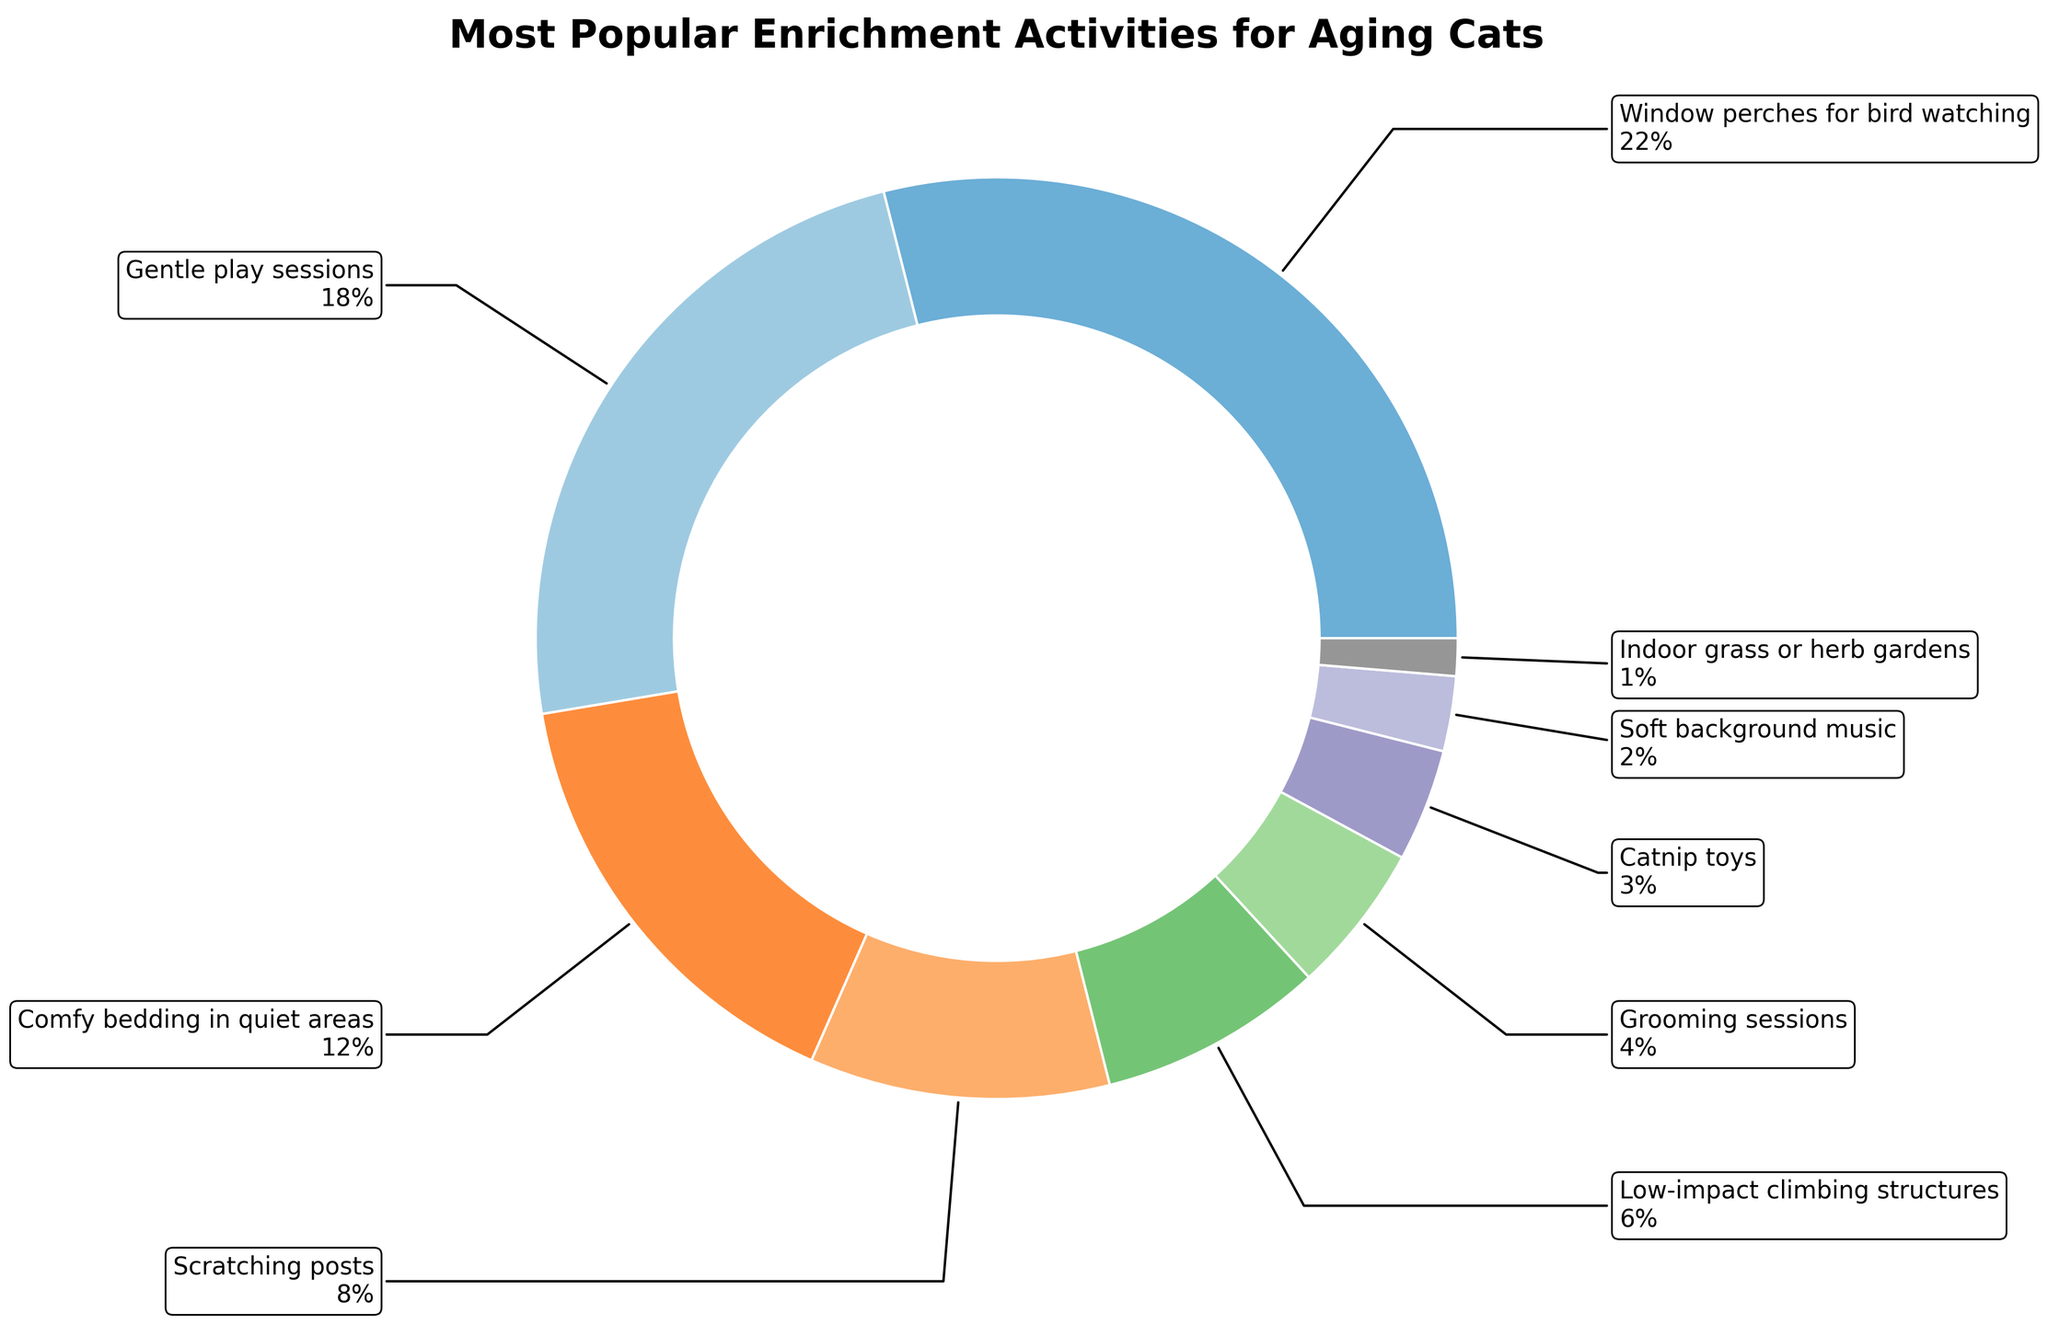What is the most popular enrichment activity for aging cats? To find the most popular activity, look for the activity with the highest percentage in the pie chart.
Answer: Window perches for bird watching What is the combined percentage of 'Gentle play sessions' and 'Comfy bedding in quiet areas'? To find the combined percentage, add the percentages of 'Gentle play sessions' (18%) and 'Comfy bedding in quiet areas' (12%).
Answer: 30% How much more popular are 'Scratching posts' compared to 'Catnip toys'? Calculate the difference between the percentage of 'Scratching posts' (8%) and 'Catnip toys' (3%).
Answer: 5% Which activity has the lowest percentage? Identify the segment with the smallest percentage on the pie chart.
Answer: Indoor grass or herb gardens Are 'Grooming sessions' more popular than 'Soft background music'? Compare the percentages of 'Grooming sessions' (4%) and 'Soft background music' (2%).
Answer: Yes What is the total percentage for activities with percentages under 10%? Add the percentages of activities that are under 10%: 'Scratching posts' (8%), 'Low-impact climbing structures' (6%), 'Grooming sessions' (4%), 'Catnip toys' (3%), 'Soft background music' (2%), and 'Indoor grass or herb gardens' (1%).
Answer: 24% Compare the popularity of 'Low-impact climbing structures' and 'Comfy bedding in quiet areas'. Which is higher? Observe the pie chart. 'Comfy bedding in quiet areas' has 12%, and 'Low-impact climbing structures' has 6%.
Answer: Comfy bedding in quiet areas If you combine 'Scratching posts' and 'Grooming sessions', what fraction of the activities do they represent? Sum the percentages of 'Scratching posts' and 'Grooming sessions', then convert it to a fraction of the total 100%. 8% + 4% = 12%, which is 12/100 or 3/25.
Answer: 3/25 Which activities share the same color theme in the pie chart? Identify segments with similar color themes in the given color scheme of the pie chart.
Answer: Varies based on the color palette, but typically segments with close percentage values may appear similar Is 'Indoor grass or herb gardens' more popular than both 'Soft background music' and 'Catnip toys' together? First, add the percentages of 'Soft background music' (2%) and 'Catnip toys' (3%), which equals 5%. Compare this with 'Indoor grass or herb gardens' (1%).
Answer: No 